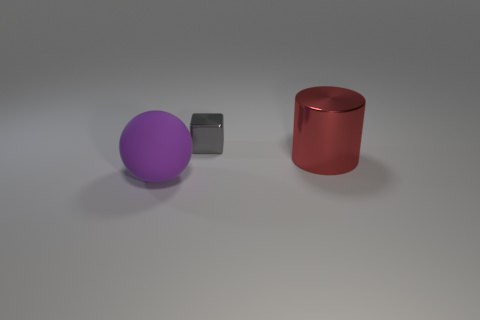How many other things are there of the same size as the gray metal cube?
Provide a succinct answer. 0. There is a object right of the tiny gray metallic object; what number of purple spheres are on the left side of it?
Provide a succinct answer. 1. Is the number of shiny objects that are in front of the shiny cylinder less than the number of metal balls?
Ensure brevity in your answer.  No. The large object in front of the shiny cylinder that is on the right side of the metallic thing that is on the left side of the red cylinder is what shape?
Your response must be concise. Sphere. Is the purple matte object the same shape as the gray metallic object?
Keep it short and to the point. No. How many other objects are there of the same shape as the large rubber object?
Offer a very short reply. 0. What color is the other object that is the same size as the red thing?
Give a very brief answer. Purple. Are there an equal number of purple objects that are on the right side of the metal cylinder and red metallic things?
Give a very brief answer. No. What shape is the thing that is in front of the gray block and left of the large red metal object?
Offer a terse response. Sphere. Is the red shiny cylinder the same size as the gray object?
Make the answer very short. No. 